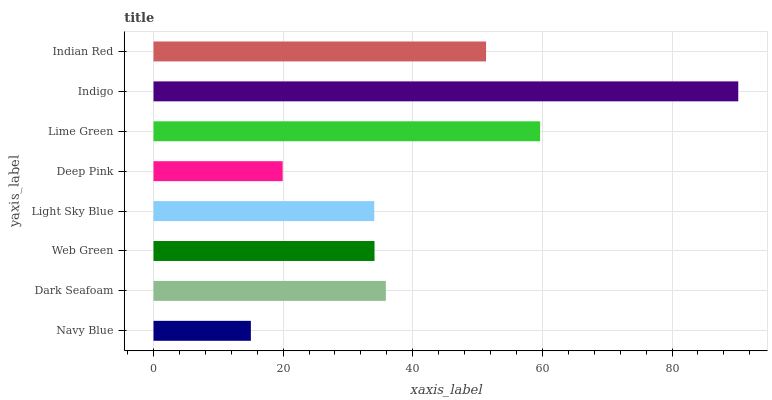Is Navy Blue the minimum?
Answer yes or no. Yes. Is Indigo the maximum?
Answer yes or no. Yes. Is Dark Seafoam the minimum?
Answer yes or no. No. Is Dark Seafoam the maximum?
Answer yes or no. No. Is Dark Seafoam greater than Navy Blue?
Answer yes or no. Yes. Is Navy Blue less than Dark Seafoam?
Answer yes or no. Yes. Is Navy Blue greater than Dark Seafoam?
Answer yes or no. No. Is Dark Seafoam less than Navy Blue?
Answer yes or no. No. Is Dark Seafoam the high median?
Answer yes or no. Yes. Is Web Green the low median?
Answer yes or no. Yes. Is Web Green the high median?
Answer yes or no. No. Is Deep Pink the low median?
Answer yes or no. No. 